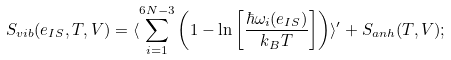Convert formula to latex. <formula><loc_0><loc_0><loc_500><loc_500>S _ { v i b } ( e _ { I S } , T , V ) = \langle \sum _ { i = 1 } ^ { 6 N - 3 } \left ( 1 - \ln \left [ \frac { \hbar { \omega } _ { i } ( e _ { I S } ) } { k _ { B } T } \right ] \right ) \rangle ^ { \prime } + S _ { a n h } ( T , V ) ;</formula> 